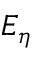Convert formula to latex. <formula><loc_0><loc_0><loc_500><loc_500>E _ { \eta }</formula> 